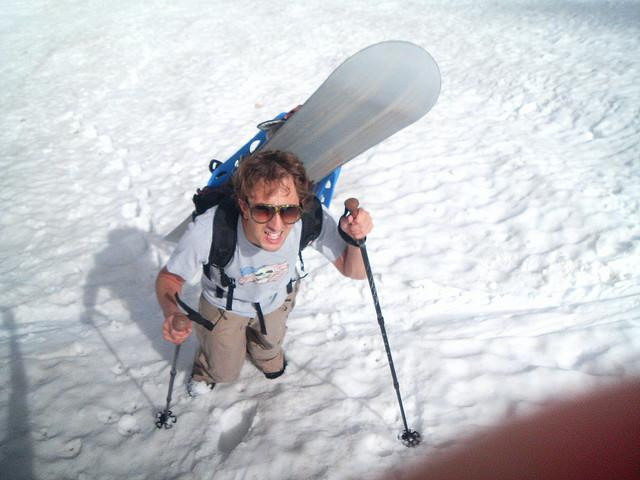What color is the bottom half of the snowboard which is carried up the hill by a man with ski poles? Please explain your reasoning. white. The snowboard has a white bottom. 